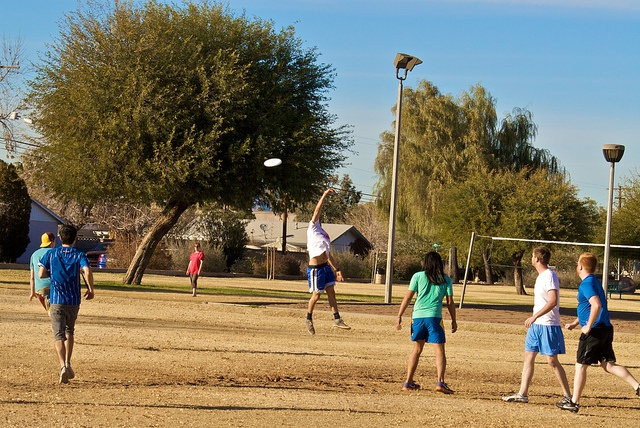Describe the objects in this image and their specific colors. I can see people in lightblue, black, maroon, tan, and teal tones, people in lightblue, black, tan, navy, and blue tones, people in lightblue, black, navy, blue, and maroon tones, people in lightblue, white, navy, and tan tones, and people in lightblue, white, maroon, black, and tan tones in this image. 